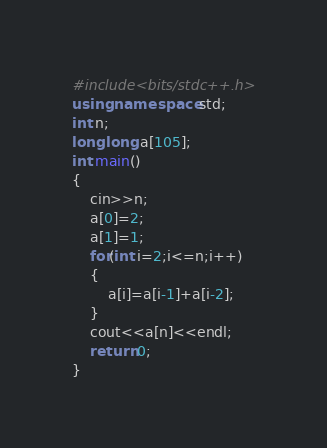Convert code to text. <code><loc_0><loc_0><loc_500><loc_500><_C++_>#include<bits/stdc++.h>
using namespace std;
int n;
long long a[105]; 
int main()
{
	cin>>n;
	a[0]=2;
	a[1]=1;
	for(int i=2;i<=n;i++)
	{
		a[i]=a[i-1]+a[i-2];
	}
	cout<<a[n]<<endl;
	return 0;
}
</code> 